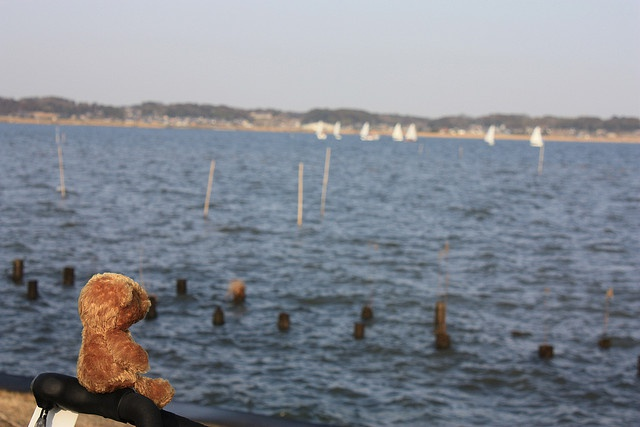Describe the objects in this image and their specific colors. I can see teddy bear in lightgray, brown, maroon, salmon, and tan tones, boat in lightgray, tan, darkgray, and gray tones, boat in lightgray, beige, darkgray, and tan tones, boat in lightgray, beige, tan, and darkgray tones, and boat in lightgray, beige, darkgray, and tan tones in this image. 